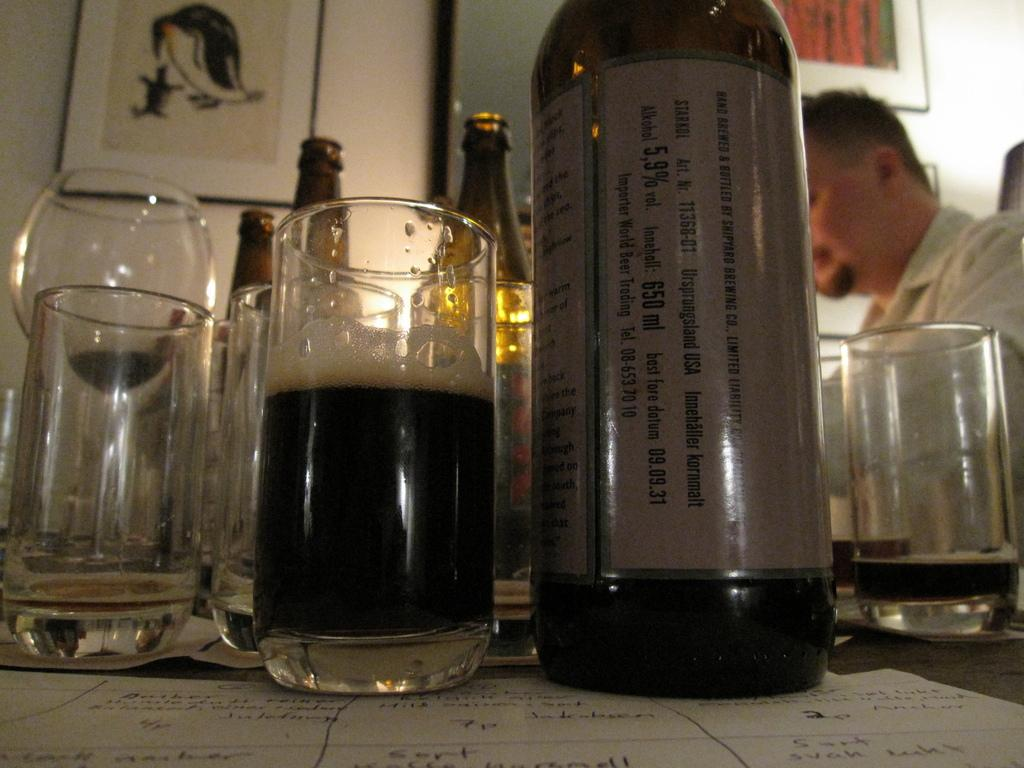What objects are on the table in the image? There are glass bottles and glasses on a table in the image. Who is present at the table in the image? A person wearing a white shirt is sitting at the table in the image. What can be seen behind the person at the table? There is a white wall behind the person in the image. What is hanging on the white wall? There are photo frames on the white wall in the image. What type of credit card is the person holding in the image? There is no credit card visible in the image; the person is sitting at a table with glass bottles, glasses, and photo frames on the wall. What kind of beast is lurking behind the person in the image? There is no beast present in the image; the person is sitting at a table with a white wall behind them. 